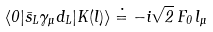<formula> <loc_0><loc_0><loc_500><loc_500>\langle 0 | { \bar { s } } _ { L } \gamma _ { \mu } d _ { L } | K ( l ) \rangle \doteq - i \sqrt { 2 } \, F _ { 0 } \, l _ { \mu }</formula> 